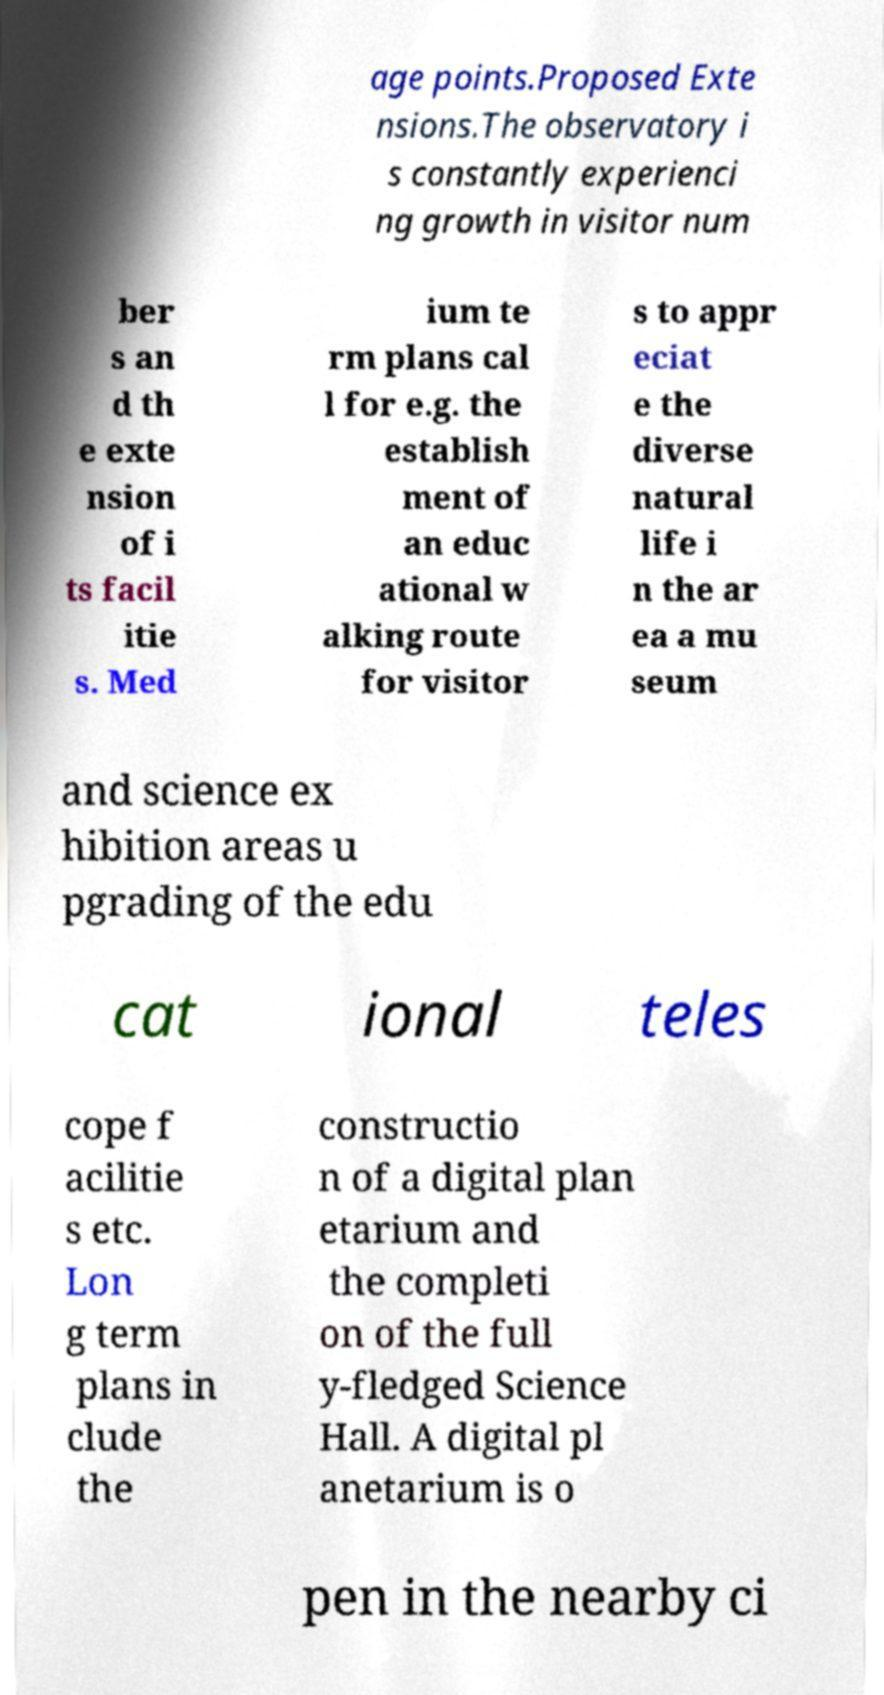Please read and relay the text visible in this image. What does it say? age points.Proposed Exte nsions.The observatory i s constantly experienci ng growth in visitor num ber s an d th e exte nsion of i ts facil itie s. Med ium te rm plans cal l for e.g. the establish ment of an educ ational w alking route for visitor s to appr eciat e the diverse natural life i n the ar ea a mu seum and science ex hibition areas u pgrading of the edu cat ional teles cope f acilitie s etc. Lon g term plans in clude the constructio n of a digital plan etarium and the completi on of the full y-fledged Science Hall. A digital pl anetarium is o pen in the nearby ci 